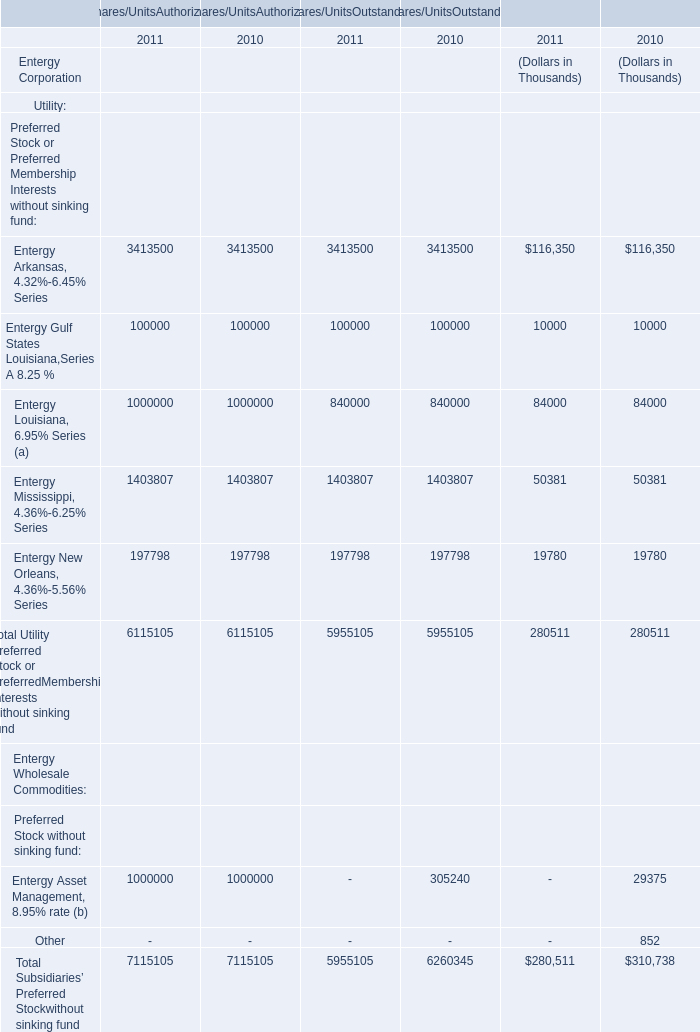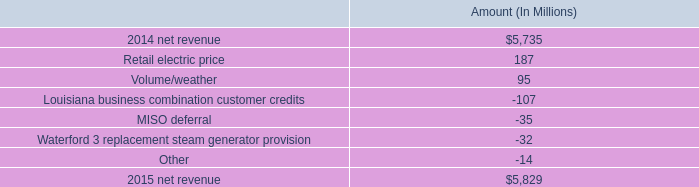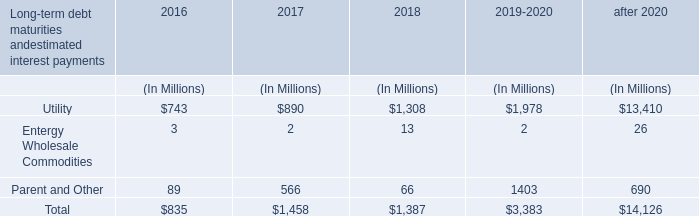what percentage of net revenue of 2015 is attributed to the growth from to retail electric price? 
Computations: (187 / 5829)
Answer: 0.03208. 